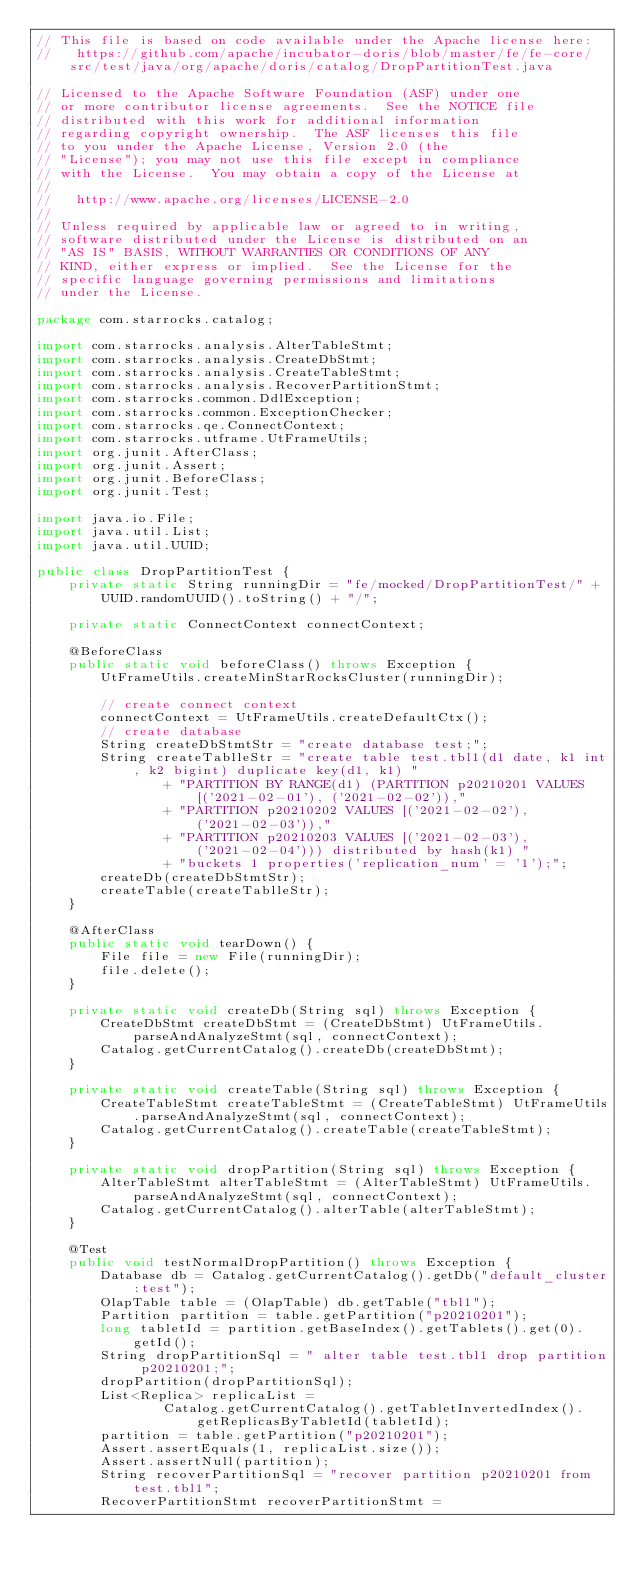<code> <loc_0><loc_0><loc_500><loc_500><_Java_>// This file is based on code available under the Apache license here:
//   https://github.com/apache/incubator-doris/blob/master/fe/fe-core/src/test/java/org/apache/doris/catalog/DropPartitionTest.java

// Licensed to the Apache Software Foundation (ASF) under one
// or more contributor license agreements.  See the NOTICE file
// distributed with this work for additional information
// regarding copyright ownership.  The ASF licenses this file
// to you under the Apache License, Version 2.0 (the
// "License"); you may not use this file except in compliance
// with the License.  You may obtain a copy of the License at
//
//   http://www.apache.org/licenses/LICENSE-2.0
//
// Unless required by applicable law or agreed to in writing,
// software distributed under the License is distributed on an
// "AS IS" BASIS, WITHOUT WARRANTIES OR CONDITIONS OF ANY
// KIND, either express or implied.  See the License for the
// specific language governing permissions and limitations
// under the License.

package com.starrocks.catalog;

import com.starrocks.analysis.AlterTableStmt;
import com.starrocks.analysis.CreateDbStmt;
import com.starrocks.analysis.CreateTableStmt;
import com.starrocks.analysis.RecoverPartitionStmt;
import com.starrocks.common.DdlException;
import com.starrocks.common.ExceptionChecker;
import com.starrocks.qe.ConnectContext;
import com.starrocks.utframe.UtFrameUtils;
import org.junit.AfterClass;
import org.junit.Assert;
import org.junit.BeforeClass;
import org.junit.Test;

import java.io.File;
import java.util.List;
import java.util.UUID;

public class DropPartitionTest {
    private static String runningDir = "fe/mocked/DropPartitionTest/" + UUID.randomUUID().toString() + "/";

    private static ConnectContext connectContext;

    @BeforeClass
    public static void beforeClass() throws Exception {
        UtFrameUtils.createMinStarRocksCluster(runningDir);

        // create connect context
        connectContext = UtFrameUtils.createDefaultCtx();
        // create database
        String createDbStmtStr = "create database test;";
        String createTablleStr = "create table test.tbl1(d1 date, k1 int, k2 bigint) duplicate key(d1, k1) "
                + "PARTITION BY RANGE(d1) (PARTITION p20210201 VALUES [('2021-02-01'), ('2021-02-02')),"
                + "PARTITION p20210202 VALUES [('2021-02-02'), ('2021-02-03')),"
                + "PARTITION p20210203 VALUES [('2021-02-03'), ('2021-02-04'))) distributed by hash(k1) "
                + "buckets 1 properties('replication_num' = '1');";
        createDb(createDbStmtStr);
        createTable(createTablleStr);
    }

    @AfterClass
    public static void tearDown() {
        File file = new File(runningDir);
        file.delete();
    }

    private static void createDb(String sql) throws Exception {
        CreateDbStmt createDbStmt = (CreateDbStmt) UtFrameUtils.parseAndAnalyzeStmt(sql, connectContext);
        Catalog.getCurrentCatalog().createDb(createDbStmt);
    }

    private static void createTable(String sql) throws Exception {
        CreateTableStmt createTableStmt = (CreateTableStmt) UtFrameUtils.parseAndAnalyzeStmt(sql, connectContext);
        Catalog.getCurrentCatalog().createTable(createTableStmt);
    }

    private static void dropPartition(String sql) throws Exception {
        AlterTableStmt alterTableStmt = (AlterTableStmt) UtFrameUtils.parseAndAnalyzeStmt(sql, connectContext);
        Catalog.getCurrentCatalog().alterTable(alterTableStmt);
    }

    @Test
    public void testNormalDropPartition() throws Exception {
        Database db = Catalog.getCurrentCatalog().getDb("default_cluster:test");
        OlapTable table = (OlapTable) db.getTable("tbl1");
        Partition partition = table.getPartition("p20210201");
        long tabletId = partition.getBaseIndex().getTablets().get(0).getId();
        String dropPartitionSql = " alter table test.tbl1 drop partition p20210201;";
        dropPartition(dropPartitionSql);
        List<Replica> replicaList =
                Catalog.getCurrentCatalog().getTabletInvertedIndex().getReplicasByTabletId(tabletId);
        partition = table.getPartition("p20210201");
        Assert.assertEquals(1, replicaList.size());
        Assert.assertNull(partition);
        String recoverPartitionSql = "recover partition p20210201 from test.tbl1";
        RecoverPartitionStmt recoverPartitionStmt =</code> 